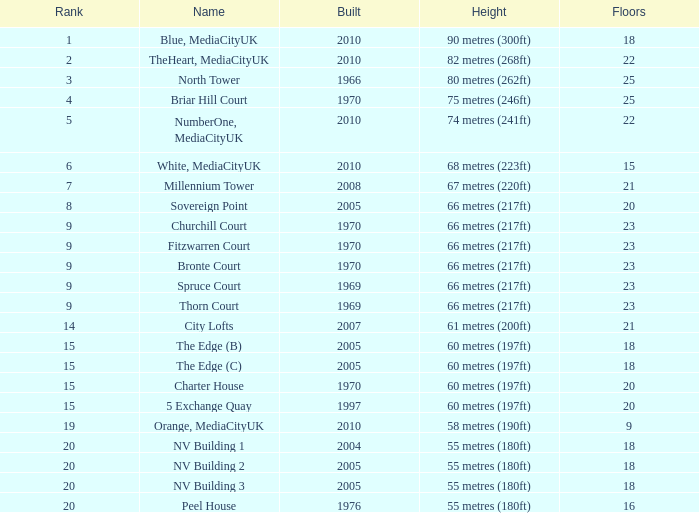What is the lowest Floors, when Built is greater than 1970, and when Name is NV Building 3? 18.0. 